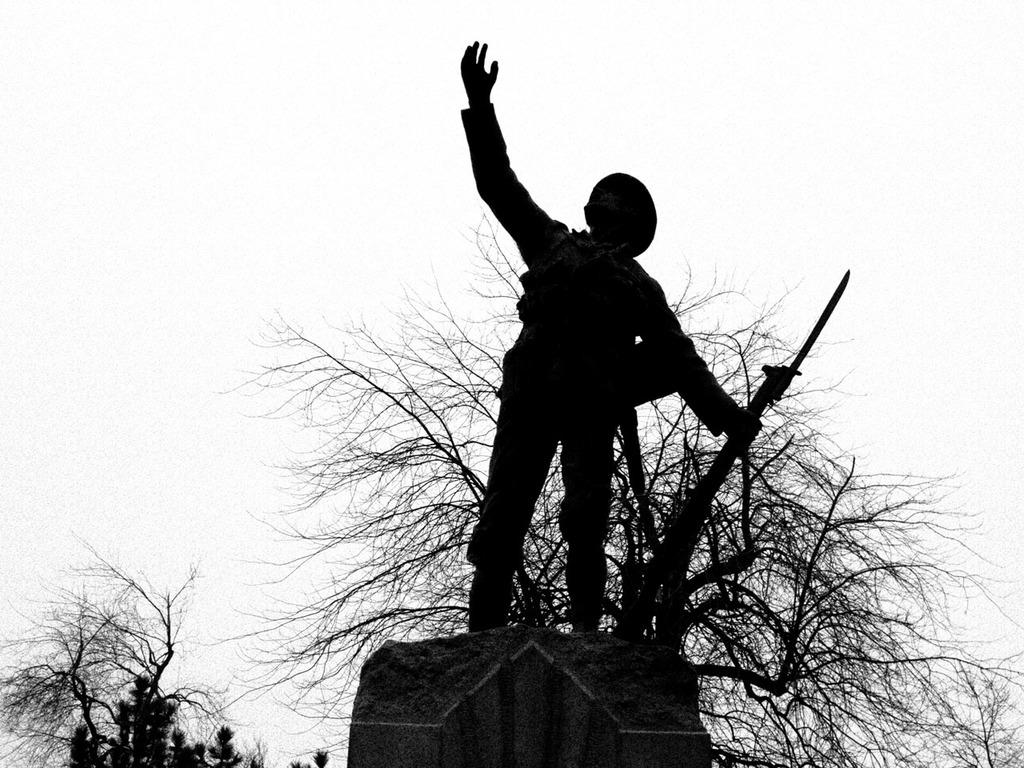What is the main subject of the image? There is a statue of a person in the image. What is the person holding in their hand? The person is holding a gun in their hand. What type of vegetation can be seen in the image? There are dried trees visible in the image. Where is the person's aunt sitting in the image? There is no mention of an aunt or any person sitting in the image; it only features a statue of a person holding a gun. 